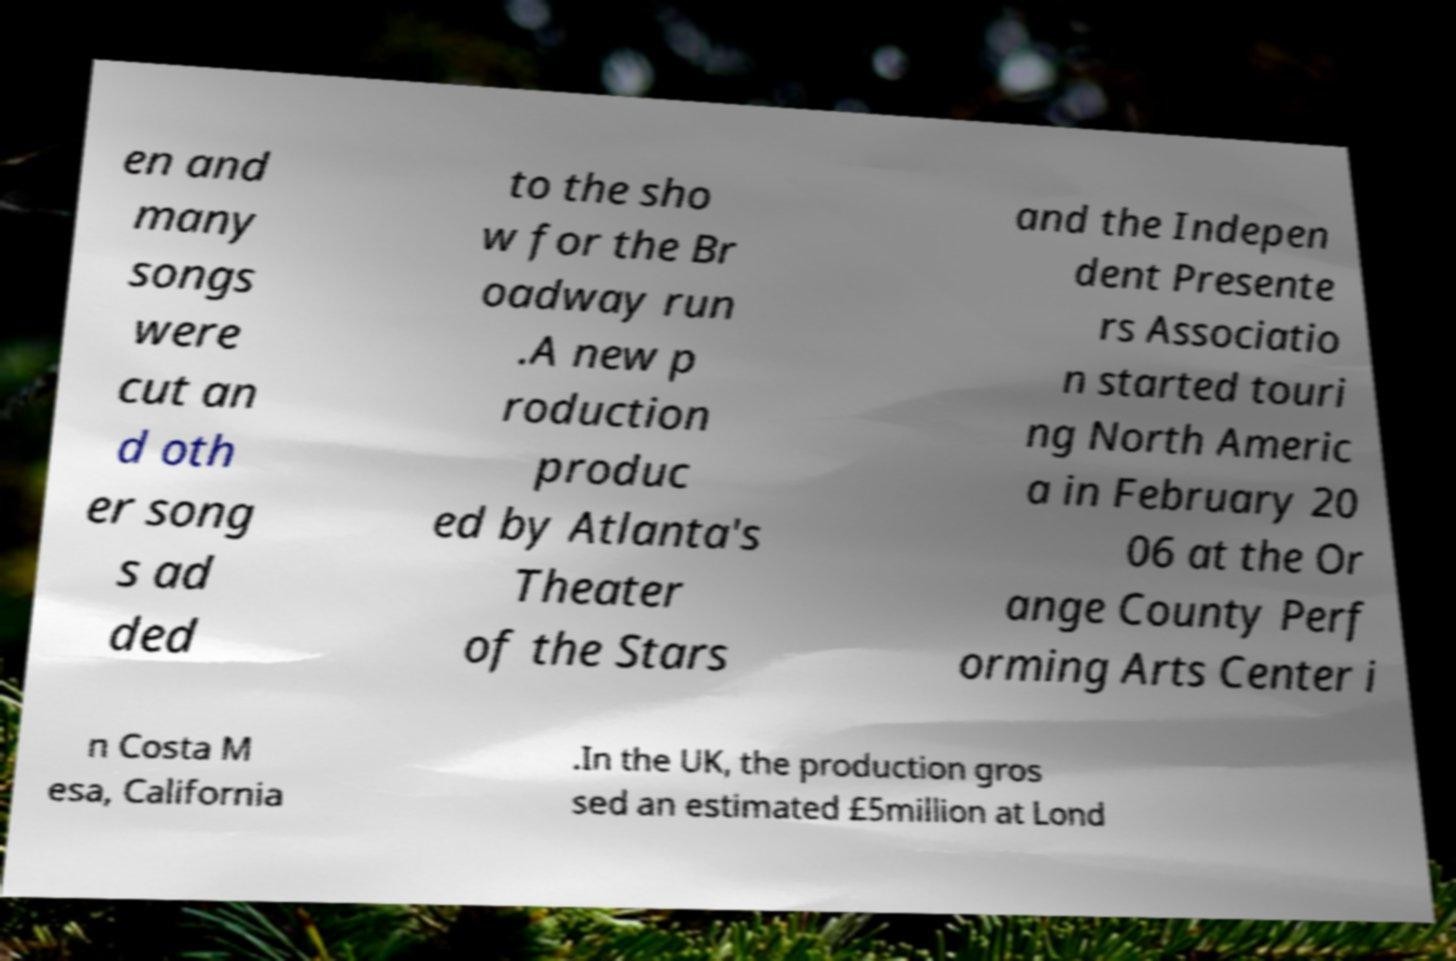Can you read and provide the text displayed in the image?This photo seems to have some interesting text. Can you extract and type it out for me? en and many songs were cut an d oth er song s ad ded to the sho w for the Br oadway run .A new p roduction produc ed by Atlanta's Theater of the Stars and the Indepen dent Presente rs Associatio n started touri ng North Americ a in February 20 06 at the Or ange County Perf orming Arts Center i n Costa M esa, California .In the UK, the production gros sed an estimated £5million at Lond 